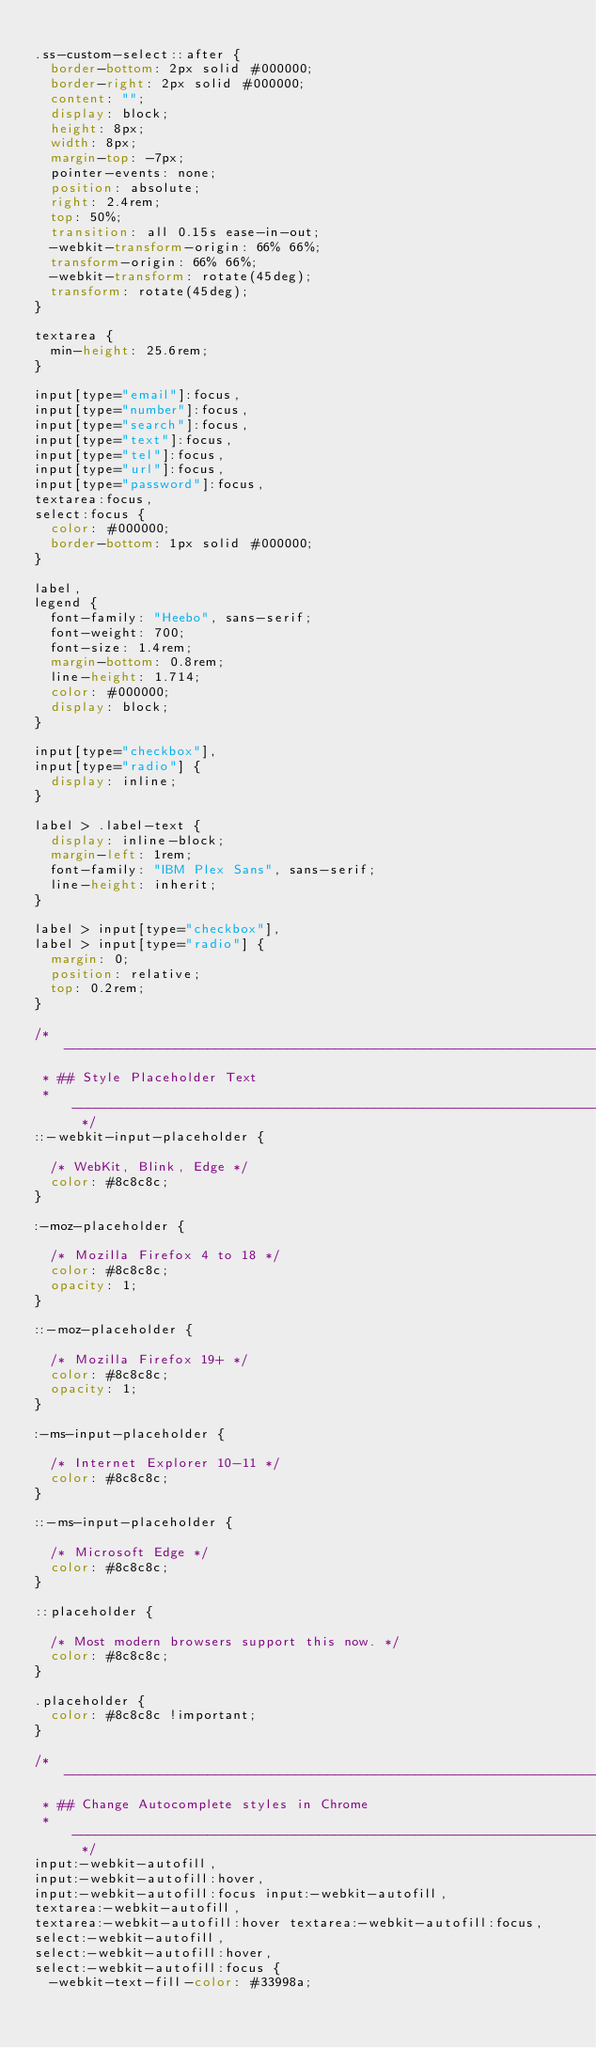<code> <loc_0><loc_0><loc_500><loc_500><_CSS_>
.ss-custom-select::after {
  border-bottom: 2px solid #000000;
  border-right: 2px solid #000000;
  content: "";
  display: block;
  height: 8px;
  width: 8px;
  margin-top: -7px;
  pointer-events: none;
  position: absolute;
  right: 2.4rem;
  top: 50%;
  transition: all 0.15s ease-in-out;
  -webkit-transform-origin: 66% 66%;
  transform-origin: 66% 66%;
  -webkit-transform: rotate(45deg);
  transform: rotate(45deg);
}

textarea {
  min-height: 25.6rem;
}

input[type="email"]:focus,
input[type="number"]:focus,
input[type="search"]:focus,
input[type="text"]:focus,
input[type="tel"]:focus,
input[type="url"]:focus,
input[type="password"]:focus,
textarea:focus,
select:focus {
  color: #000000;
  border-bottom: 1px solid #000000;
}

label,
legend {
  font-family: "Heebo", sans-serif;
  font-weight: 700;
  font-size: 1.4rem;
  margin-bottom: 0.8rem;
  line-height: 1.714;
  color: #000000;
  display: block;
}

input[type="checkbox"],
input[type="radio"] {
  display: inline;
}

label > .label-text {
  display: inline-block;
  margin-left: 1rem;
  font-family: "IBM Plex Sans", sans-serif;
  line-height: inherit;
}

label > input[type="checkbox"],
label > input[type="radio"] {
  margin: 0;
  position: relative;
  top: 0.2rem;
}

/* ------------------------------------------------------------------- 
 * ## Style Placeholder Text
 * ------------------------------------------------------------------- */
::-webkit-input-placeholder {

  /* WebKit, Blink, Edge */
  color: #8c8c8c;
}

:-moz-placeholder {

  /* Mozilla Firefox 4 to 18 */
  color: #8c8c8c;
  opacity: 1;
}

::-moz-placeholder {

  /* Mozilla Firefox 19+ */
  color: #8c8c8c;
  opacity: 1;
}

:-ms-input-placeholder {

  /* Internet Explorer 10-11 */
  color: #8c8c8c;
}

::-ms-input-placeholder {

  /* Microsoft Edge */
  color: #8c8c8c;
}

::placeholder {

  /* Most modern browsers support this now. */
  color: #8c8c8c;
}

.placeholder {
  color: #8c8c8c !important;
}

/* ------------------------------------------------------------------- 
 * ## Change Autocomplete styles in Chrome
 * ------------------------------------------------------------------- */
input:-webkit-autofill,
input:-webkit-autofill:hover,
input:-webkit-autofill:focus input:-webkit-autofill,
textarea:-webkit-autofill,
textarea:-webkit-autofill:hover textarea:-webkit-autofill:focus,
select:-webkit-autofill,
select:-webkit-autofill:hover,
select:-webkit-autofill:focus {
  -webkit-text-fill-color: #33998a;</code> 